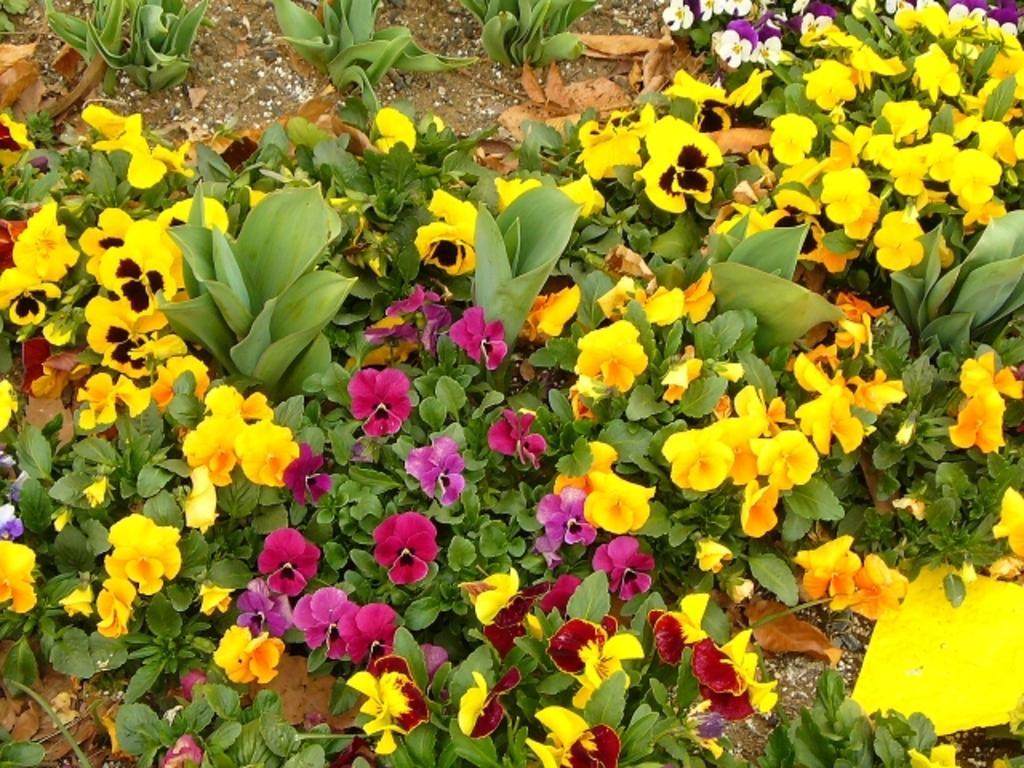How would you summarize this image in a sentence or two? In this picture, we can see some plants and a few plants with flowers, and we can see the ground. 